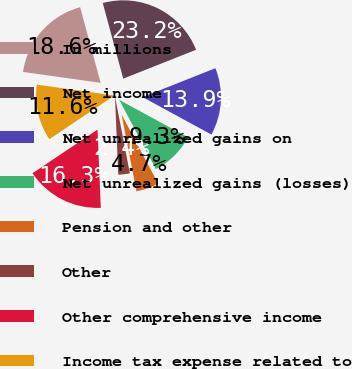<chart> <loc_0><loc_0><loc_500><loc_500><pie_chart><fcel>In millions<fcel>Net income<fcel>Net unrealized gains on<fcel>Net unrealized gains (losses)<fcel>Pension and other<fcel>Other<fcel>Other comprehensive income<fcel>Income tax expense related to<nl><fcel>18.57%<fcel>23.2%<fcel>13.95%<fcel>9.32%<fcel>4.7%<fcel>2.38%<fcel>16.26%<fcel>11.63%<nl></chart> 